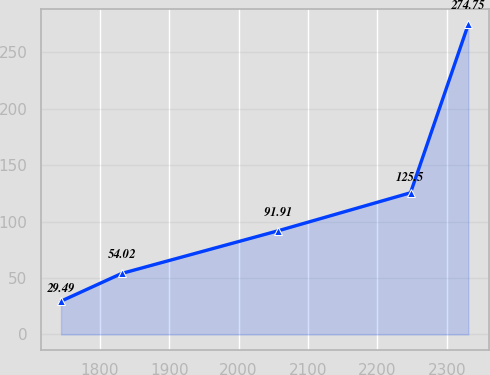Convert chart to OTSL. <chart><loc_0><loc_0><loc_500><loc_500><line_chart><ecel><fcel>Unnamed: 1<nl><fcel>1744.24<fcel>29.49<nl><fcel>1831.62<fcel>54.02<nl><fcel>2057.54<fcel>91.91<nl><fcel>2247.83<fcel>125.5<nl><fcel>2331.11<fcel>274.75<nl></chart> 